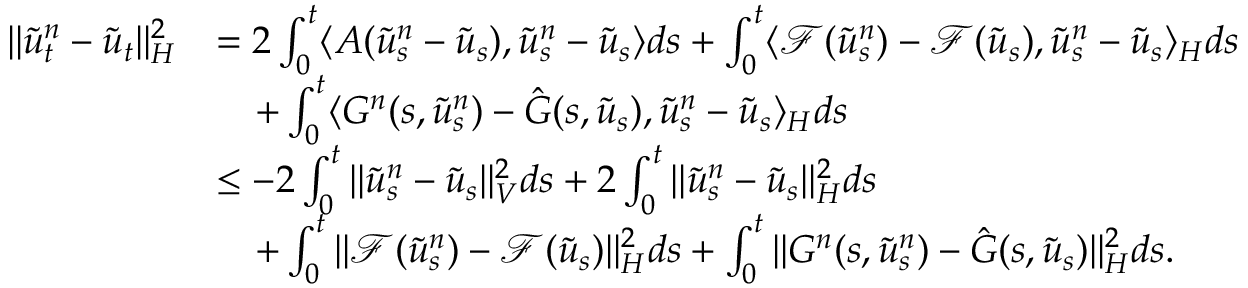Convert formula to latex. <formula><loc_0><loc_0><loc_500><loc_500>\begin{array} { r l } { \| \tilde { u } _ { t } ^ { n } - \tilde { u } _ { t } \| _ { H } ^ { 2 } } & { = 2 \int _ { 0 } ^ { t } \langle A ( \tilde { u } _ { s } ^ { n } - \tilde { u } _ { s } ) , \tilde { u } _ { s } ^ { n } - \tilde { u } _ { s } \rangle d s + \int _ { 0 } ^ { t } \langle \mathcal { F } ( \tilde { u } _ { s } ^ { n } ) - \mathcal { F } ( \tilde { u } _ { s } ) , \tilde { u } _ { s } ^ { n } - \tilde { u } _ { s } \rangle _ { H } d s } \\ & { \quad + \int _ { 0 } ^ { t } \langle G ^ { n } ( s , \tilde { u } _ { s } ^ { n } ) - \hat { G } ( s , \tilde { u } _ { s } ) , \tilde { u } _ { s } ^ { n } - \tilde { u } _ { s } \rangle _ { H } d s } \\ & { \leq - 2 \int _ { 0 } ^ { t } \| \tilde { u } _ { s } ^ { n } - \tilde { u } _ { s } \| _ { V } ^ { 2 } d s + 2 \int _ { 0 } ^ { t } \| \tilde { u } _ { s } ^ { n } - \tilde { u } _ { s } \| _ { H } ^ { 2 } d s } \\ & { \quad + \int _ { 0 } ^ { t } \| \mathcal { F } ( \tilde { u } _ { s } ^ { n } ) - \mathcal { F } ( \tilde { u } _ { s } ) \| _ { H } ^ { 2 } d s + \int _ { 0 } ^ { t } \| G ^ { n } ( s , \tilde { u } _ { s } ^ { n } ) - \hat { G } ( s , \tilde { u } _ { s } ) \| _ { H } ^ { 2 } d s . } \end{array}</formula> 